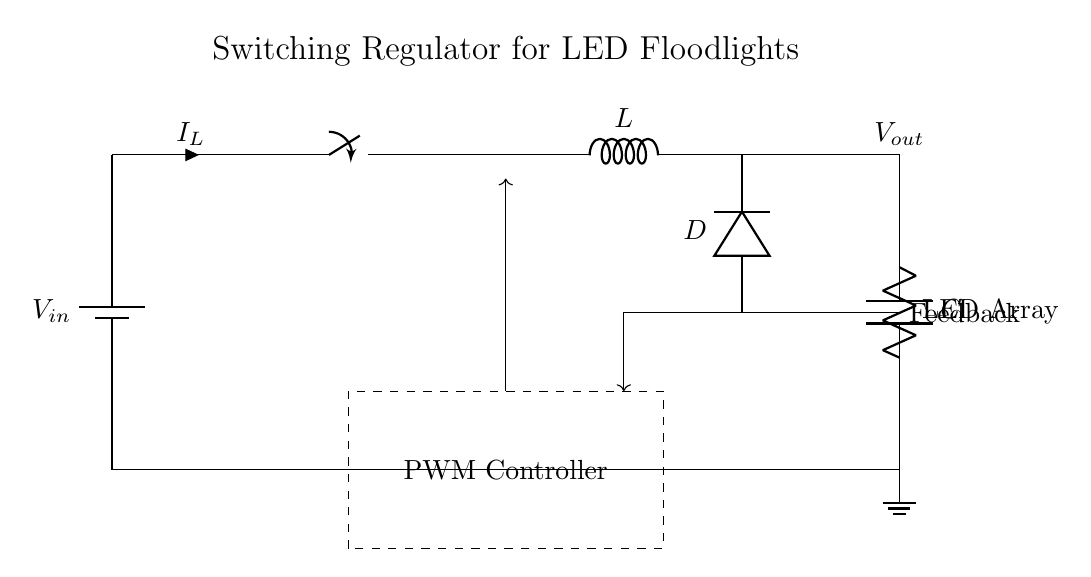What is the input voltage of this circuit? The input voltage is represented by V_in, which is connected to the circuit's power supply. It is typically the voltage source that powers the switching regulator.
Answer: V_in What component is used to store energy? The component used to store energy in the circuit is the inductor, labeled as L. It absorbs energy when the switch is on and releases it when the switch is off.
Answer: L What is the output voltage of the circuit? The output voltage is indicated by V_out, which is the voltage supplied to the LED array. It is generated based on the switching action of the regulator and the energy stored in the inductor.
Answer: V_out Which component regulates the output voltage? The output voltage is regulated by the PWM controller, which adjusts the duty cycle of the switch to control the energy delivered to the load.
Answer: PWM Controller What role does the diode play in this circuit? The diode, labeled D, prevents backflow of current when the switch is off, ensuring that the inductor discharges energy only into the load and not back into the circuit.
Answer: Prevents backflow What is the purpose of the capacitor in this circuit? The capacitor, labeled C, smooths the output voltage by storing and releasing charge, which minimizes voltage ripple and provides a stable supply to the LED array.
Answer: Smooths voltage How does feedback contribute to the operation of this circuit? Feedback is used to monitor the output voltage and adjust the PWM controller's operation to maintain a stable output. This ensures that fluctuations in load do not affect the voltage supplied to the LEDs.
Answer: Maintains stability 